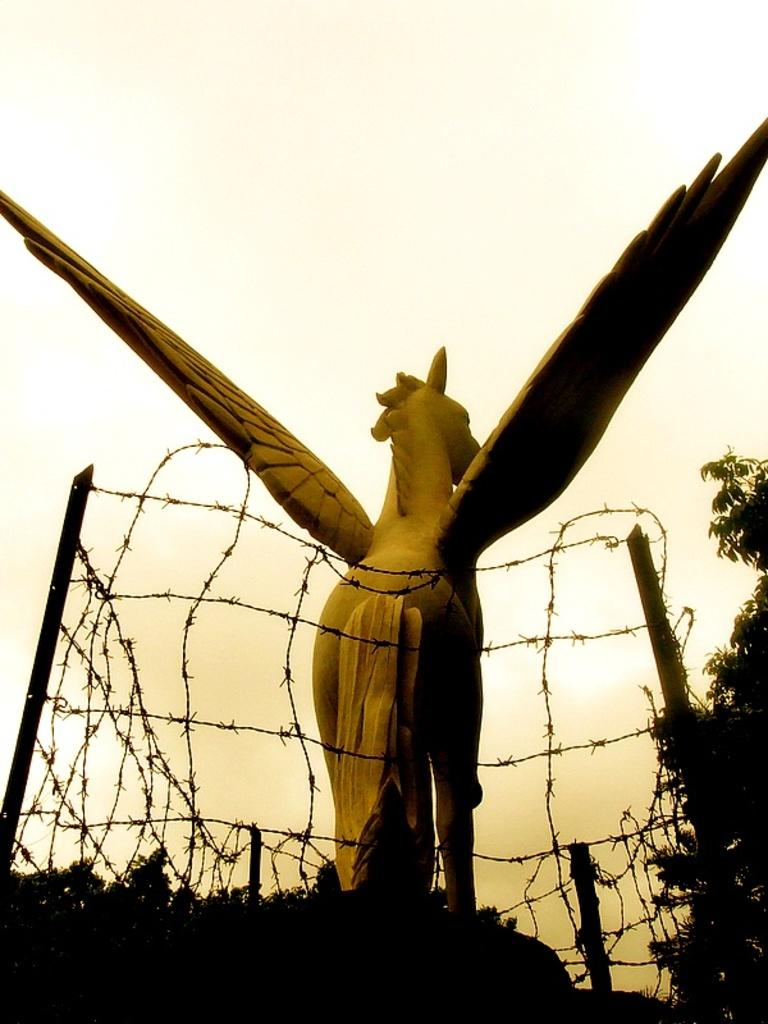What is the main subject in the image? There is a statue in the image. What surrounds the statue? There is a fence with poles around the statue. What type of vegetation is present in the image? There are trees in the image. What can be seen in the background of the image? The sky is visible in the background of the image. What type of bird is having a discussion with the statue in the image? There is no bird present in the image, and therefore no discussion can be observed. 